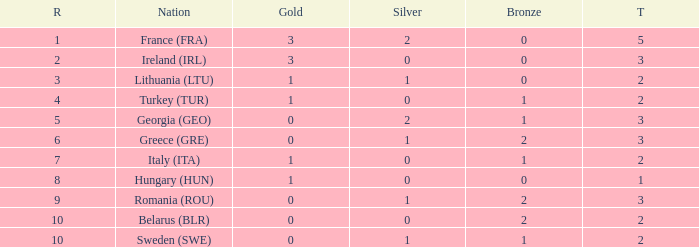Would you mind parsing the complete table? {'header': ['R', 'Nation', 'Gold', 'Silver', 'Bronze', 'T'], 'rows': [['1', 'France (FRA)', '3', '2', '0', '5'], ['2', 'Ireland (IRL)', '3', '0', '0', '3'], ['3', 'Lithuania (LTU)', '1', '1', '0', '2'], ['4', 'Turkey (TUR)', '1', '0', '1', '2'], ['5', 'Georgia (GEO)', '0', '2', '1', '3'], ['6', 'Greece (GRE)', '0', '1', '2', '3'], ['7', 'Italy (ITA)', '1', '0', '1', '2'], ['8', 'Hungary (HUN)', '1', '0', '0', '1'], ['9', 'Romania (ROU)', '0', '1', '2', '3'], ['10', 'Belarus (BLR)', '0', '0', '2', '2'], ['10', 'Sweden (SWE)', '0', '1', '1', '2']]} What's the total when the gold is less than 0 and silver is less than 1? None. 